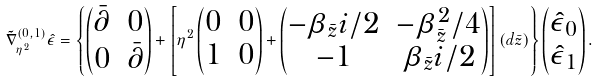Convert formula to latex. <formula><loc_0><loc_0><loc_500><loc_500>\tilde { \nabla } _ { \eta ^ { 2 } } ^ { ( 0 , 1 ) } \hat { \epsilon } = \left \{ \begin{pmatrix} \bar { \partial } & 0 \\ 0 & \bar { \partial } \end{pmatrix} + \left [ \eta ^ { 2 } \begin{pmatrix} 0 & 0 \\ 1 & 0 \end{pmatrix} + \begin{pmatrix} - \beta _ { \bar { z } } i / 2 & - \beta _ { \bar { z } } ^ { 2 } / 4 \\ - 1 & \beta _ { \bar { z } } i / 2 \end{pmatrix} \right ] ( d \bar { z } ) \right \} \begin{pmatrix} \hat { \epsilon } _ { 0 } \\ \hat { \epsilon } _ { 1 } \end{pmatrix} .</formula> 